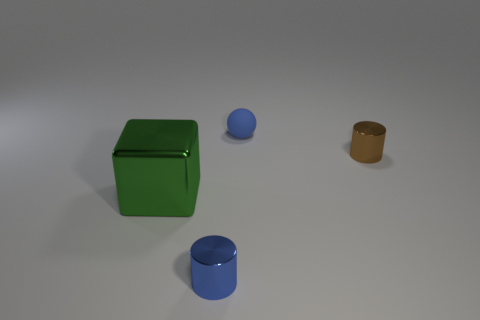There is a cylinder right of the blue object in front of the large shiny block; what color is it?
Your answer should be very brief. Brown. Are there an equal number of small brown metallic things that are on the left side of the small blue matte sphere and green metal things on the left side of the large green metal block?
Offer a terse response. Yes. Are the tiny cylinder in front of the big metallic cube and the tiny blue ball made of the same material?
Offer a terse response. No. The object that is on the right side of the shiny cube and left of the blue ball is what color?
Provide a short and direct response. Blue. How many small blue cylinders are to the right of the thing that is in front of the green block?
Offer a very short reply. 0. What material is the other object that is the same shape as the tiny brown thing?
Your response must be concise. Metal. What color is the small matte thing?
Provide a short and direct response. Blue. What number of things are small blue matte things or big green objects?
Make the answer very short. 2. There is a tiny blue thing right of the blue object in front of the blue rubber ball; what shape is it?
Your answer should be very brief. Sphere. What number of other objects are there of the same material as the tiny blue sphere?
Your answer should be very brief. 0. 